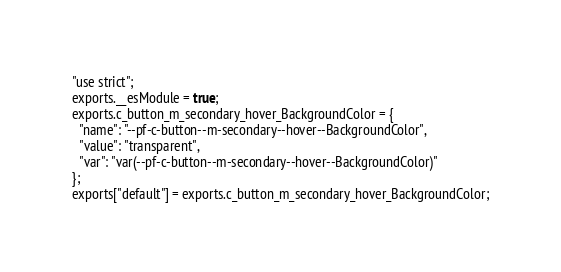Convert code to text. <code><loc_0><loc_0><loc_500><loc_500><_JavaScript_>"use strict";
exports.__esModule = true;
exports.c_button_m_secondary_hover_BackgroundColor = {
  "name": "--pf-c-button--m-secondary--hover--BackgroundColor",
  "value": "transparent",
  "var": "var(--pf-c-button--m-secondary--hover--BackgroundColor)"
};
exports["default"] = exports.c_button_m_secondary_hover_BackgroundColor;</code> 